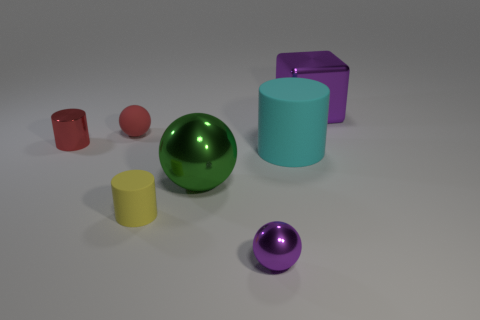Are there the same number of objects to the left of the tiny yellow matte cylinder and cyan rubber cylinders that are left of the cyan thing?
Make the answer very short. No. There is a green metallic object that is the same shape as the red matte thing; what size is it?
Provide a succinct answer. Large. The purple thing in front of the cyan rubber thing has what shape?
Your answer should be compact. Sphere. Are the purple thing behind the yellow cylinder and the large cyan object on the right side of the large metallic sphere made of the same material?
Provide a short and direct response. No. What shape is the yellow matte object?
Provide a succinct answer. Cylinder. Are there an equal number of big metal spheres right of the large purple thing and yellow matte cylinders?
Give a very brief answer. No. The thing that is the same color as the big shiny cube is what size?
Provide a short and direct response. Small. Are there any large things made of the same material as the large green sphere?
Offer a terse response. Yes. There is a small metallic object that is right of the matte ball; is its shape the same as the large thing that is behind the large cyan object?
Your response must be concise. No. Are any large cyan shiny cubes visible?
Your answer should be very brief. No. 